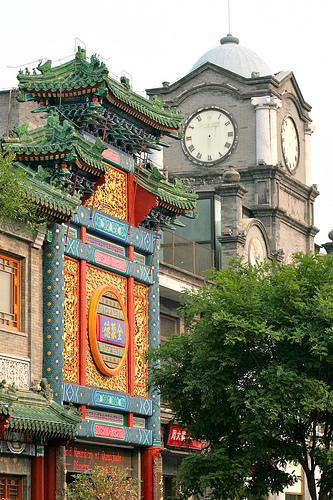Question: when does this scene occur?
Choices:
A. Daytime.
B. Nighttime.
C. Dusk.
D. Dawn.
Answer with the letter. Answer: A Question: what language is in the circle on the gold building?
Choices:
A. English.
B. French.
C. Italian.
D. Asian language.
Answer with the letter. Answer: D Question: where is the domed roof?
Choices:
A. Over the house.
B. On top of the water tower.
C. Above the clock.
D. On top of the silo.
Answer with the letter. Answer: C Question: what color is the clock building?
Choices:
A. White.
B. Brown.
C. Gray.
D. Red.
Answer with the letter. Answer: C Question: where are the trees?
Choices:
A. In the garden.
B. In the backyard.
C. To the right of the Asian building.
D. On the side of the highway.
Answer with the letter. Answer: C 